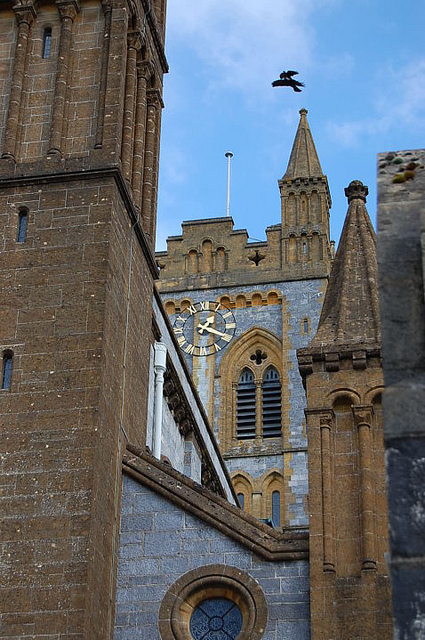<image>How tall are the buildings? It is unknown how tall the buildings are. They could be very tall or many stories high. What point of view is this picture taken? I am not sure what point of view the picture is taken. It can be seen from the ground, upward or above. How tall are the buildings? It is unanswerable how tall the buildings are. What point of view is this picture taken? I don't know from what point of view this picture is taken. 